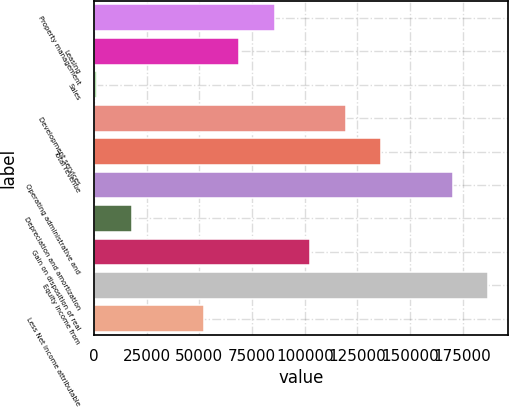<chart> <loc_0><loc_0><loc_500><loc_500><bar_chart><fcel>Property management<fcel>Leasing<fcel>Sales<fcel>Development services<fcel>Total revenue<fcel>Operating administrative and<fcel>Depreciation and amortization<fcel>Gain on disposition of real<fcel>Equity income from<fcel>Less Net income attributable<nl><fcel>85754.5<fcel>68870.2<fcel>1333<fcel>119523<fcel>136407<fcel>170176<fcel>18217.3<fcel>102639<fcel>187060<fcel>51985.9<nl></chart> 